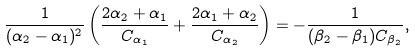<formula> <loc_0><loc_0><loc_500><loc_500>\frac { 1 } { ( \alpha _ { 2 } - \alpha _ { 1 } ) ^ { 2 } } \left ( \frac { 2 \alpha _ { 2 } + \alpha _ { 1 } } { C _ { \alpha _ { 1 } } } + \frac { 2 \alpha _ { 1 } + \alpha _ { 2 } } { C _ { \alpha _ { 2 } } } \right ) = - \frac { 1 } { ( \beta _ { 2 } - \beta _ { 1 } ) C _ { \beta _ { 2 } } } ,</formula> 